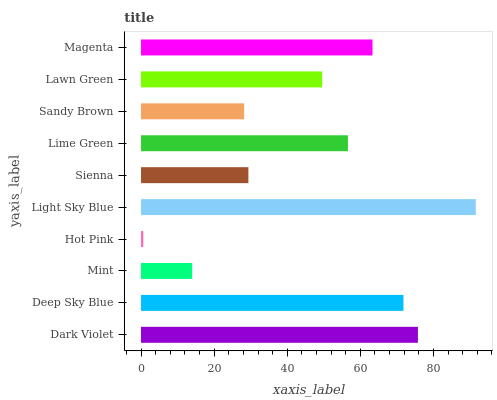Is Hot Pink the minimum?
Answer yes or no. Yes. Is Light Sky Blue the maximum?
Answer yes or no. Yes. Is Deep Sky Blue the minimum?
Answer yes or no. No. Is Deep Sky Blue the maximum?
Answer yes or no. No. Is Dark Violet greater than Deep Sky Blue?
Answer yes or no. Yes. Is Deep Sky Blue less than Dark Violet?
Answer yes or no. Yes. Is Deep Sky Blue greater than Dark Violet?
Answer yes or no. No. Is Dark Violet less than Deep Sky Blue?
Answer yes or no. No. Is Lime Green the high median?
Answer yes or no. Yes. Is Lawn Green the low median?
Answer yes or no. Yes. Is Dark Violet the high median?
Answer yes or no. No. Is Mint the low median?
Answer yes or no. No. 